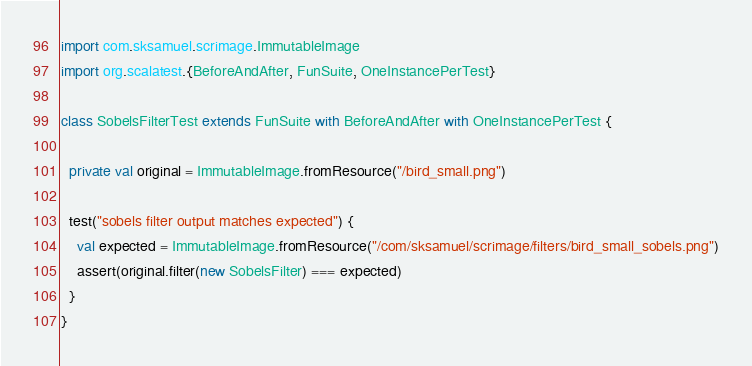<code> <loc_0><loc_0><loc_500><loc_500><_Scala_>import com.sksamuel.scrimage.ImmutableImage
import org.scalatest.{BeforeAndAfter, FunSuite, OneInstancePerTest}

class SobelsFilterTest extends FunSuite with BeforeAndAfter with OneInstancePerTest {

  private val original = ImmutableImage.fromResource("/bird_small.png")

  test("sobels filter output matches expected") {
    val expected = ImmutableImage.fromResource("/com/sksamuel/scrimage/filters/bird_small_sobels.png")
    assert(original.filter(new SobelsFilter) === expected)
  }
}
</code> 